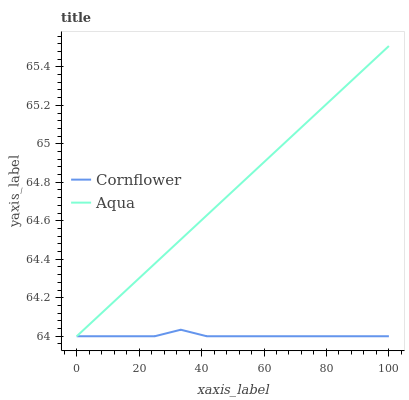Does Aqua have the minimum area under the curve?
Answer yes or no. No. Is Aqua the roughest?
Answer yes or no. No. 